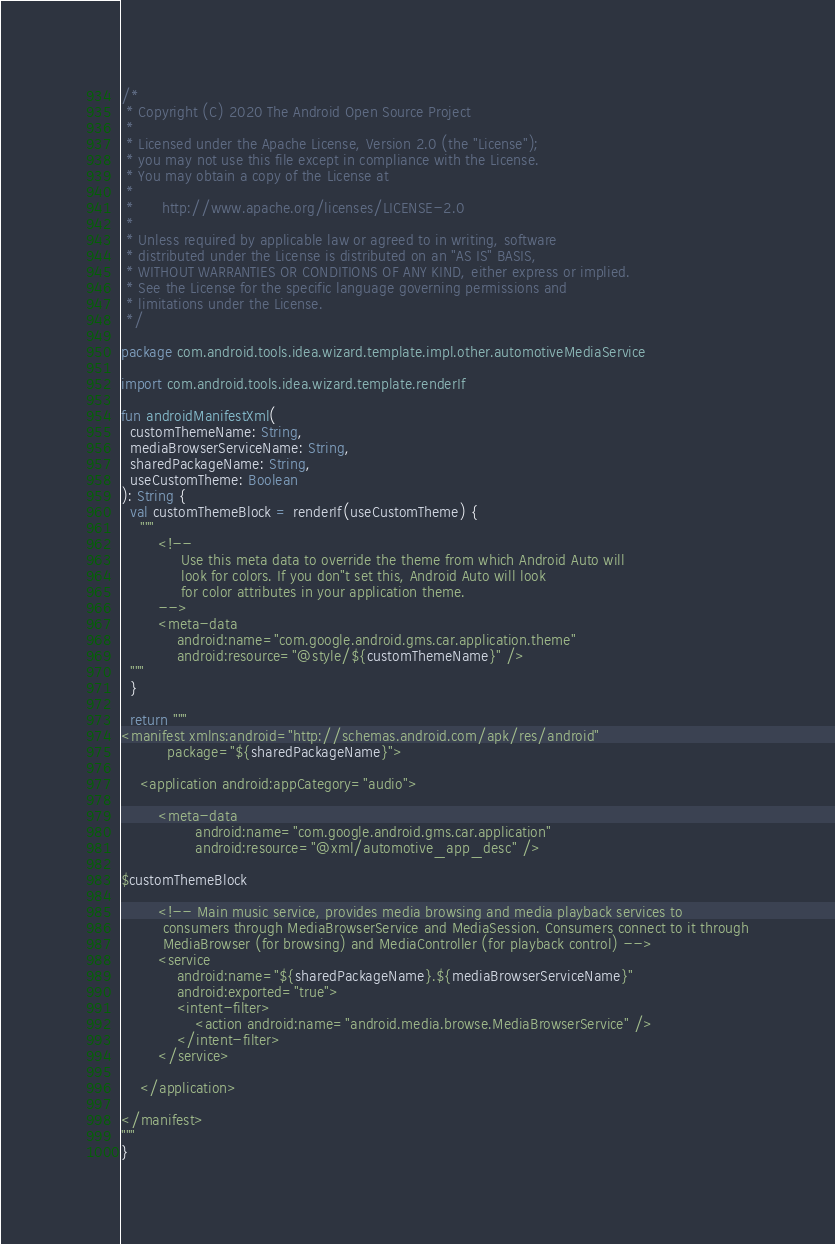<code> <loc_0><loc_0><loc_500><loc_500><_Kotlin_>/*
 * Copyright (C) 2020 The Android Open Source Project
 *
 * Licensed under the Apache License, Version 2.0 (the "License");
 * you may not use this file except in compliance with the License.
 * You may obtain a copy of the License at
 *
 *      http://www.apache.org/licenses/LICENSE-2.0
 *
 * Unless required by applicable law or agreed to in writing, software
 * distributed under the License is distributed on an "AS IS" BASIS,
 * WITHOUT WARRANTIES OR CONDITIONS OF ANY KIND, either express or implied.
 * See the License for the specific language governing permissions and
 * limitations under the License.
 */

package com.android.tools.idea.wizard.template.impl.other.automotiveMediaService

import com.android.tools.idea.wizard.template.renderIf

fun androidManifestXml(
  customThemeName: String,
  mediaBrowserServiceName: String,
  sharedPackageName: String,
  useCustomTheme: Boolean
): String {
  val customThemeBlock = renderIf(useCustomTheme) {
    """
        <!--
             Use this meta data to override the theme from which Android Auto will
             look for colors. If you don"t set this, Android Auto will look
             for color attributes in your application theme.
        -->
        <meta-data
            android:name="com.google.android.gms.car.application.theme"
            android:resource="@style/${customThemeName}" />
  """
  }

  return """
<manifest xmlns:android="http://schemas.android.com/apk/res/android"
          package="${sharedPackageName}">

    <application android:appCategory="audio">

        <meta-data
                android:name="com.google.android.gms.car.application"
                android:resource="@xml/automotive_app_desc" />

$customThemeBlock

        <!-- Main music service, provides media browsing and media playback services to
         consumers through MediaBrowserService and MediaSession. Consumers connect to it through
         MediaBrowser (for browsing) and MediaController (for playback control) -->
        <service
            android:name="${sharedPackageName}.${mediaBrowserServiceName}"
            android:exported="true">
            <intent-filter>
                <action android:name="android.media.browse.MediaBrowserService" />
            </intent-filter>
        </service>

    </application>

</manifest>
"""
}
</code> 